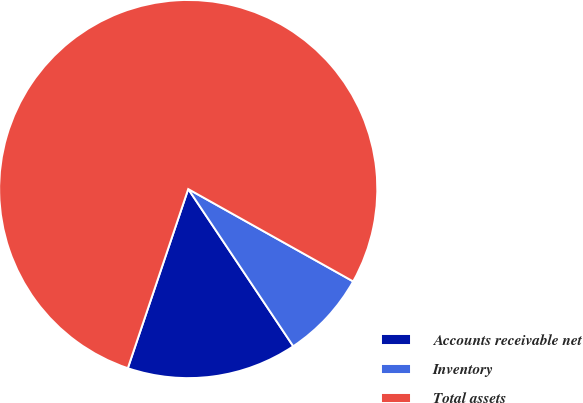Convert chart to OTSL. <chart><loc_0><loc_0><loc_500><loc_500><pie_chart><fcel>Accounts receivable net<fcel>Inventory<fcel>Total assets<nl><fcel>14.55%<fcel>7.5%<fcel>77.95%<nl></chart> 